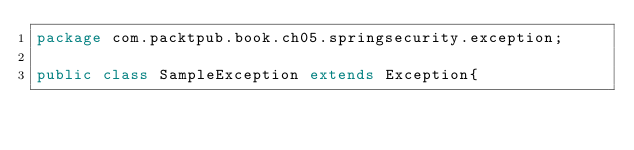<code> <loc_0><loc_0><loc_500><loc_500><_Java_>package com.packtpub.book.ch05.springsecurity.exception;

public class SampleException extends Exception{
</code> 